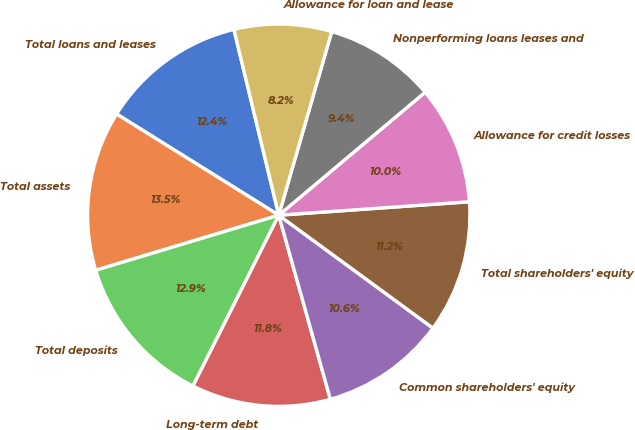Convert chart to OTSL. <chart><loc_0><loc_0><loc_500><loc_500><pie_chart><fcel>Total loans and leases<fcel>Total assets<fcel>Total deposits<fcel>Long-term debt<fcel>Common shareholders' equity<fcel>Total shareholders' equity<fcel>Allowance for credit losses<fcel>Nonperforming loans leases and<fcel>Allowance for loan and lease<nl><fcel>12.35%<fcel>13.53%<fcel>12.94%<fcel>11.76%<fcel>10.59%<fcel>11.18%<fcel>10.0%<fcel>9.41%<fcel>8.24%<nl></chart> 